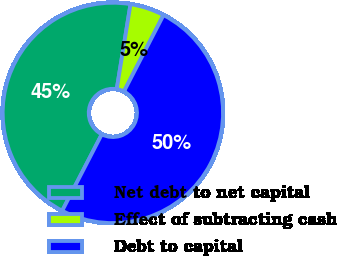Convert chart. <chart><loc_0><loc_0><loc_500><loc_500><pie_chart><fcel>Net debt to net capital<fcel>Effect of subtracting cash<fcel>Debt to capital<nl><fcel>44.96%<fcel>5.04%<fcel>50.0%<nl></chart> 